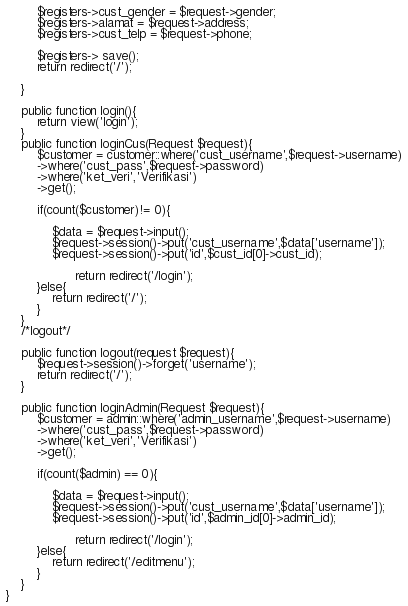Convert code to text. <code><loc_0><loc_0><loc_500><loc_500><_PHP_>        $registers->cust_gender = $request->gender;
        $registers->alamat = $request->address;
        $registers->cust_telp = $request->phone;

        $registers-> save();
        return redirect('/');
        
    }

    public function login(){
        return view('login');
    }
    public function loginCus(Request $request){
        $customer = customer::where('cust_username',$request->username)
        ->where('cust_pass',$request->password)
        ->where('ket_veri','Verifikasi')
        ->get();

        if(count($customer)!= 0){

            $data = $request->input();
            $request->session()->put('cust_username',$data['username']);
            $request->session()->put('id',$cust_id[0]->cust_id);
            
                  return redirect('/login');
        }else{
            return redirect('/');
        }
    }
    /*logout*/

    public function logout(request $request){
        $request->session()->forget('username');
        return redirect('/');
    }

    public function loginAdmin(Request $request){
        $customer = admin::where('admin_username',$request->username)
        ->where('cust_pass',$request->password)
        ->where('ket_veri','Verifikasi')
        ->get();

        if(count($admin) == 0){

            $data = $request->input();
            $request->session()->put('cust_username',$data['username']);
            $request->session()->put('id',$admin_id[0]->admin_id);
            
                  return redirect('/login');
        }else{
            return redirect('/editmenu');
        }
    }
}
</code> 